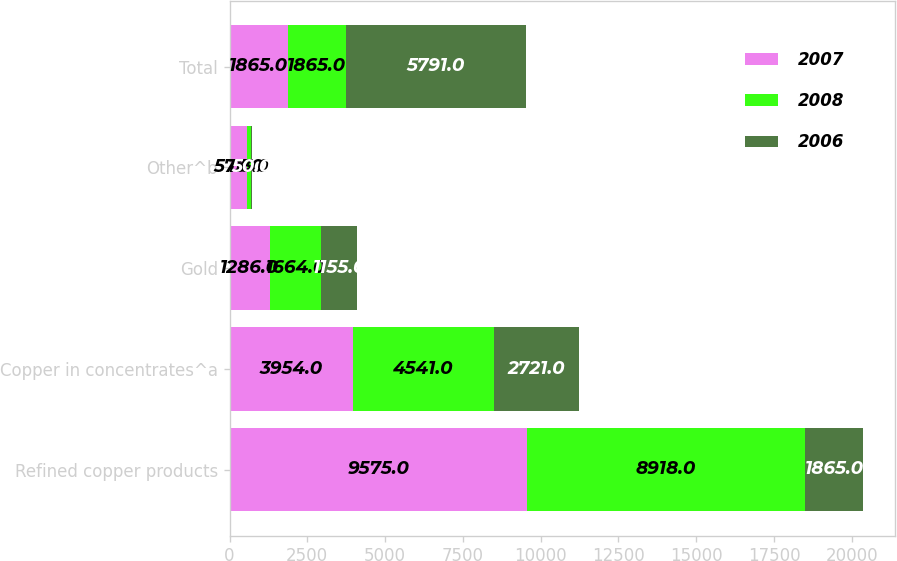<chart> <loc_0><loc_0><loc_500><loc_500><stacked_bar_chart><ecel><fcel>Refined copper products<fcel>Copper in concentrates^a<fcel>Gold<fcel>Other^b<fcel>Total<nl><fcel>2007<fcel>9575<fcel>3954<fcel>1286<fcel>573<fcel>1865<nl><fcel>2008<fcel>8918<fcel>4541<fcel>1664<fcel>113<fcel>1865<nl><fcel>2006<fcel>1865<fcel>2721<fcel>1155<fcel>50<fcel>5791<nl></chart> 